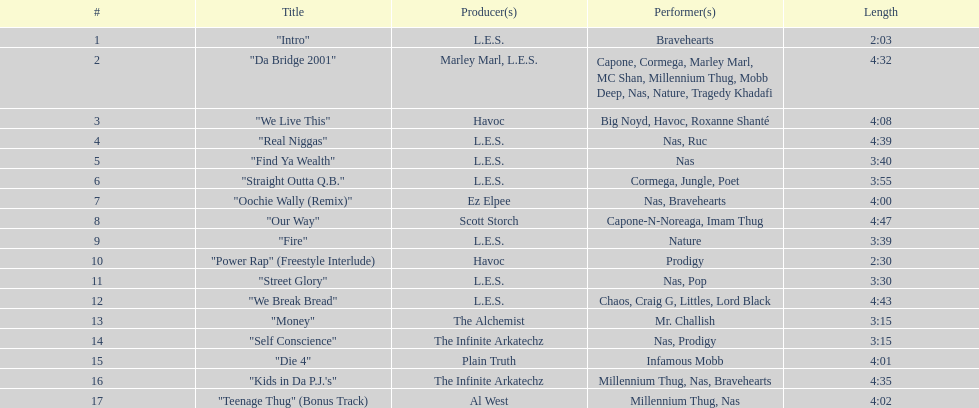How long is the shortest song on the album? 2:03. 